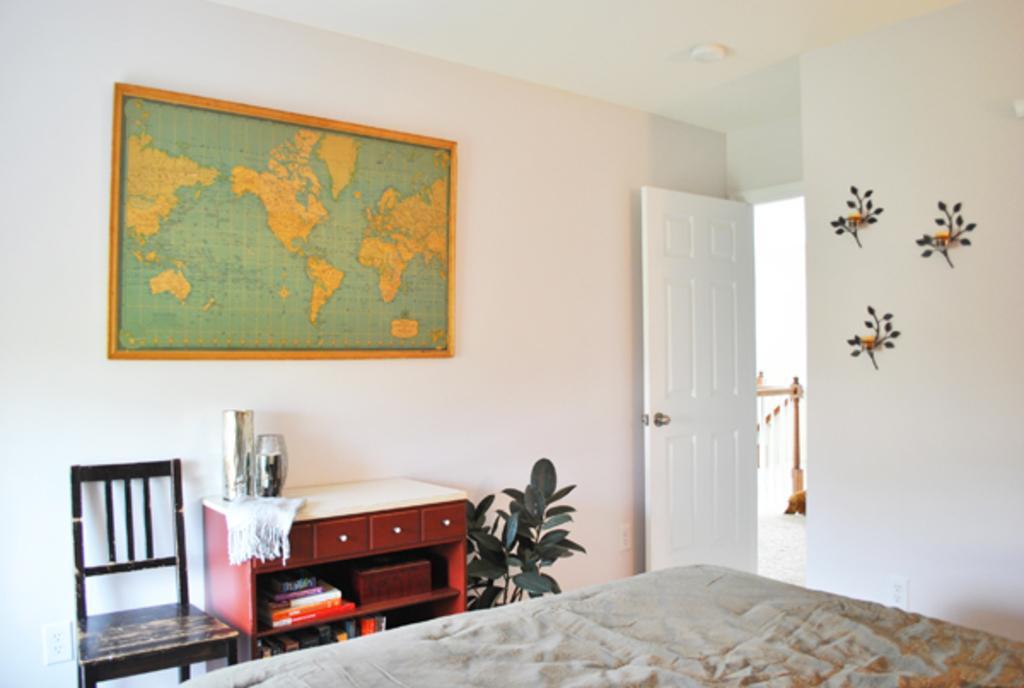How would you summarize this image in a sentence or two? This is a door which is used to enter into to the room. Here we can see a wooden shelf where a books and clothes are kept on it. This is a chair. This is a bed. This is a world map which is fixed to a wall. 